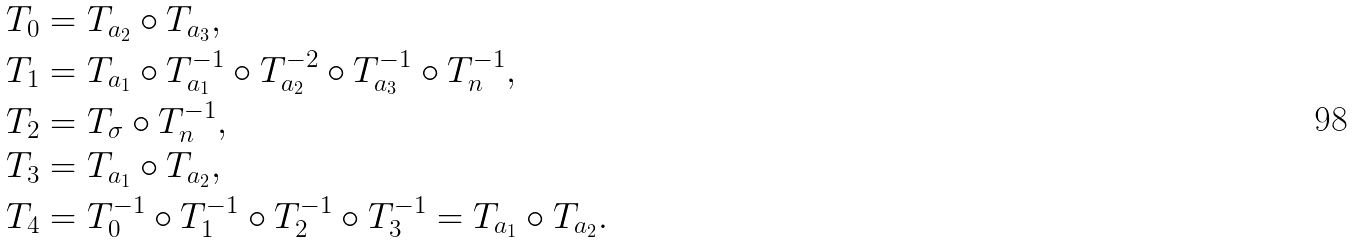Convert formula to latex. <formula><loc_0><loc_0><loc_500><loc_500>T _ { 0 } & = T _ { a _ { 2 } } \circ T _ { a _ { 3 } } , \\ T _ { 1 } & = T _ { a _ { 1 } } \circ T _ { a _ { 1 } } ^ { - 1 } \circ T _ { a _ { 2 } } ^ { - 2 } \circ T _ { a _ { 3 } } ^ { - 1 } \circ T _ { n } ^ { - 1 } , \\ T _ { 2 } & = T _ { \sigma } \circ T _ { n } ^ { - 1 } , \\ T _ { 3 } & = T _ { a _ { 1 } } \circ T _ { a _ { 2 } } , \\ T _ { 4 } & = T _ { 0 } ^ { - 1 } \circ T _ { 1 } ^ { - 1 } \circ T _ { 2 } ^ { - 1 } \circ T _ { 3 } ^ { - 1 } = T _ { a _ { 1 } } \circ T _ { a _ { 2 } } .</formula> 